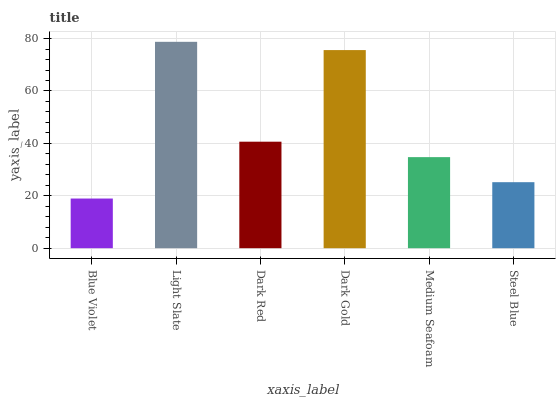Is Blue Violet the minimum?
Answer yes or no. Yes. Is Light Slate the maximum?
Answer yes or no. Yes. Is Dark Red the minimum?
Answer yes or no. No. Is Dark Red the maximum?
Answer yes or no. No. Is Light Slate greater than Dark Red?
Answer yes or no. Yes. Is Dark Red less than Light Slate?
Answer yes or no. Yes. Is Dark Red greater than Light Slate?
Answer yes or no. No. Is Light Slate less than Dark Red?
Answer yes or no. No. Is Dark Red the high median?
Answer yes or no. Yes. Is Medium Seafoam the low median?
Answer yes or no. Yes. Is Steel Blue the high median?
Answer yes or no. No. Is Blue Violet the low median?
Answer yes or no. No. 